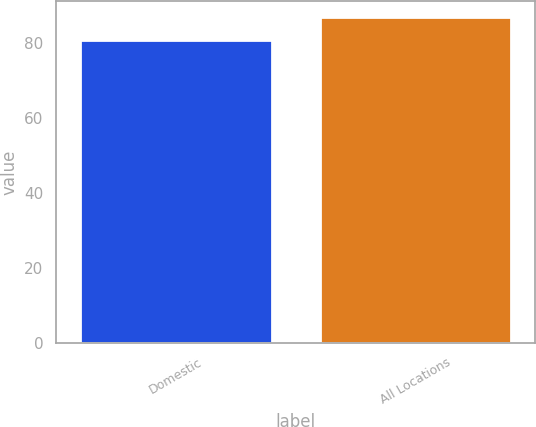Convert chart. <chart><loc_0><loc_0><loc_500><loc_500><bar_chart><fcel>Domestic<fcel>All Locations<nl><fcel>81<fcel>87<nl></chart> 